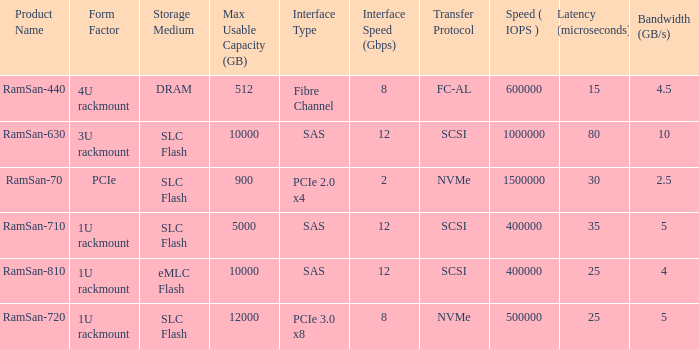What is the Input/output operations per second for the emlc flash? 400000.0. 